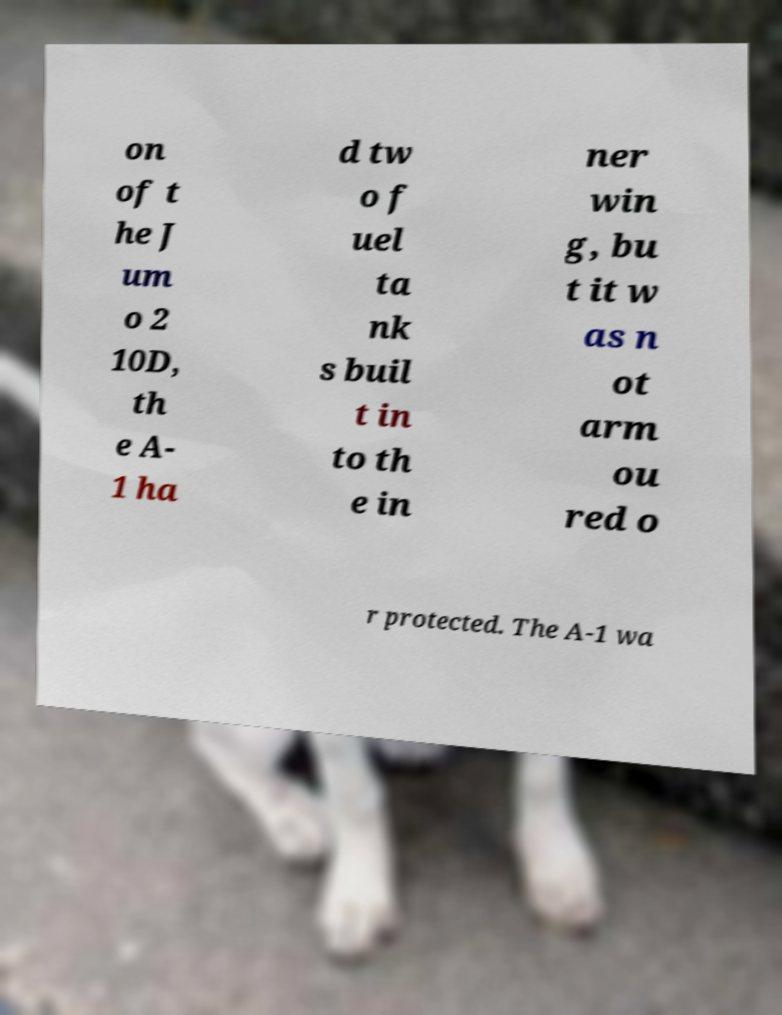I need the written content from this picture converted into text. Can you do that? on of t he J um o 2 10D, th e A- 1 ha d tw o f uel ta nk s buil t in to th e in ner win g, bu t it w as n ot arm ou red o r protected. The A-1 wa 